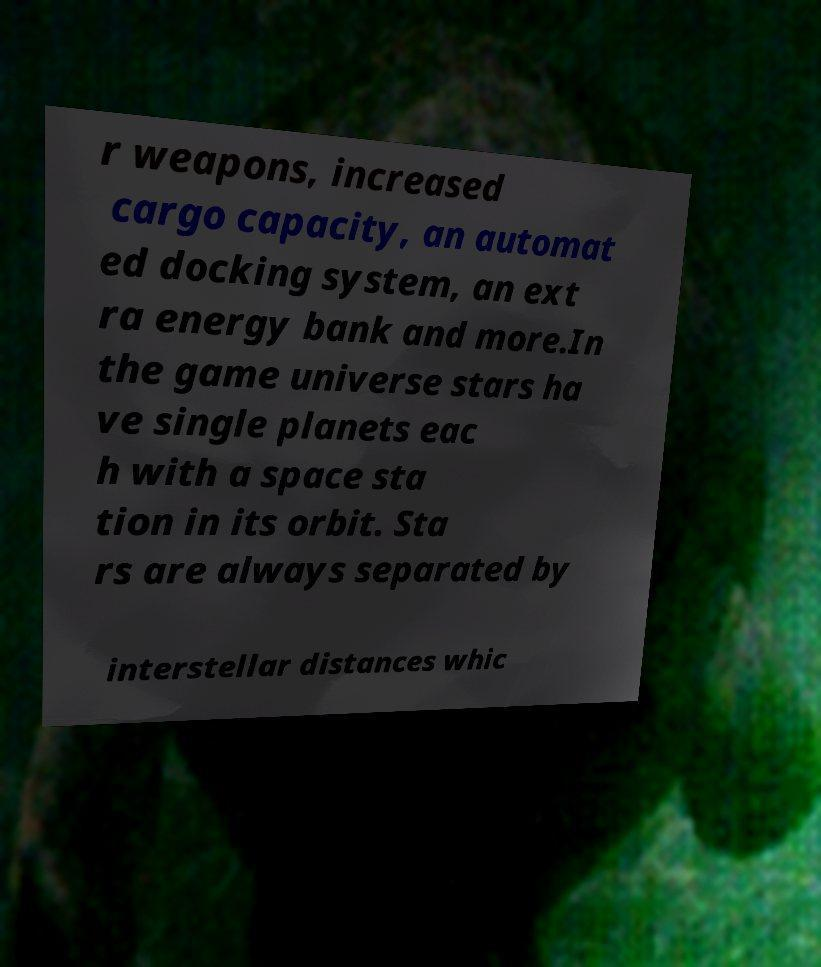Could you assist in decoding the text presented in this image and type it out clearly? r weapons, increased cargo capacity, an automat ed docking system, an ext ra energy bank and more.In the game universe stars ha ve single planets eac h with a space sta tion in its orbit. Sta rs are always separated by interstellar distances whic 